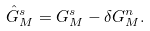<formula> <loc_0><loc_0><loc_500><loc_500>\hat { G } _ { M } ^ { s } = G _ { M } ^ { s } - \delta G _ { M } ^ { n } .</formula> 